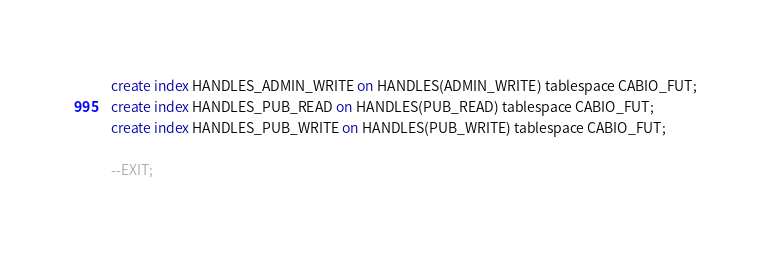Convert code to text. <code><loc_0><loc_0><loc_500><loc_500><_SQL_>create index HANDLES_ADMIN_WRITE on HANDLES(ADMIN_WRITE) tablespace CABIO_FUT;
create index HANDLES_PUB_READ on HANDLES(PUB_READ) tablespace CABIO_FUT;
create index HANDLES_PUB_WRITE on HANDLES(PUB_WRITE) tablespace CABIO_FUT;

--EXIT;
</code> 